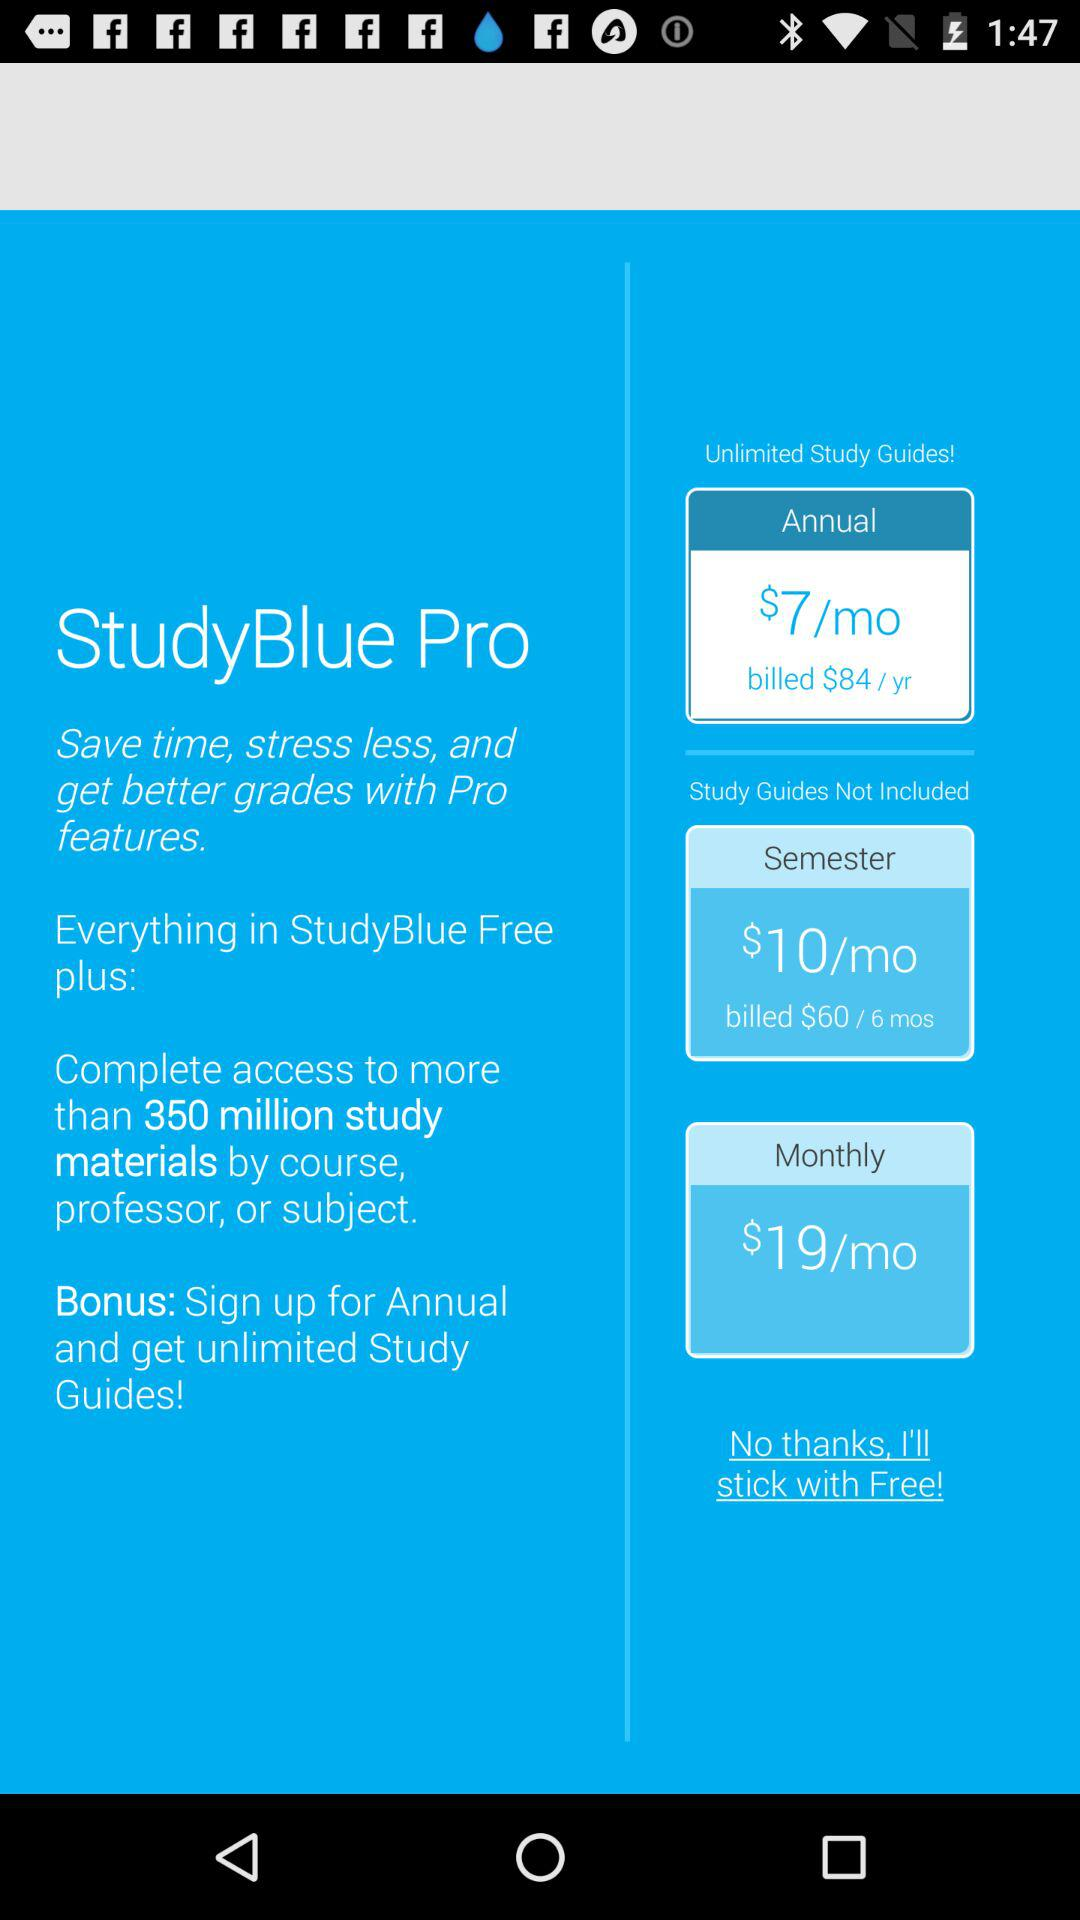What is the application name? The application name is "StudyBlue Pro". 